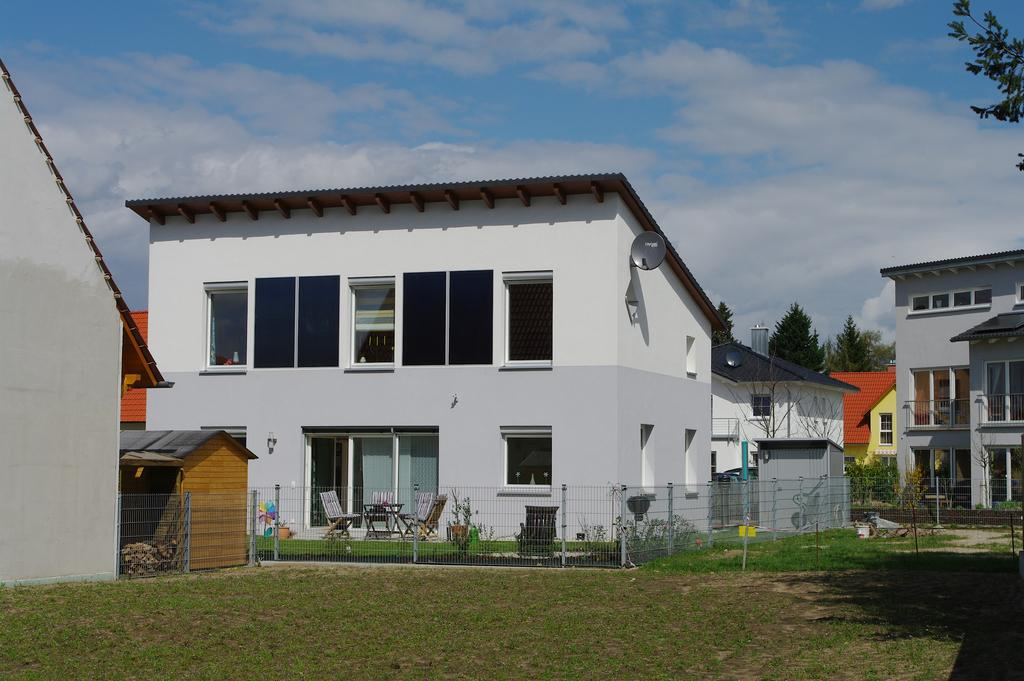What type of structures can be seen in the image? There are buildings with windows and houses in the image. What is on the ground in the image? The ground with grass is visible in the image. What type of vegetation is present in the image? Trees are present in the image. What type of seating is visible in the image? Chairs are visible in the image. What type of barrier is present in the image? There is fencing in the image. What is visible in the sky in the image? The sky with clouds is visible in the image. What color is the scarf worn by the beetle in the image? There is no beetle or scarf present in the image. What statement does the image make about the environment? The image does not make a statement about the environment; it simply depicts a scene with buildings, houses, trees, chairs, fencing, and the sky. 